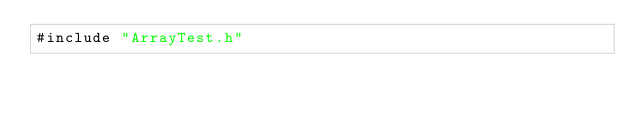<code> <loc_0><loc_0><loc_500><loc_500><_Cuda_>#include "ArrayTest.h"</code> 